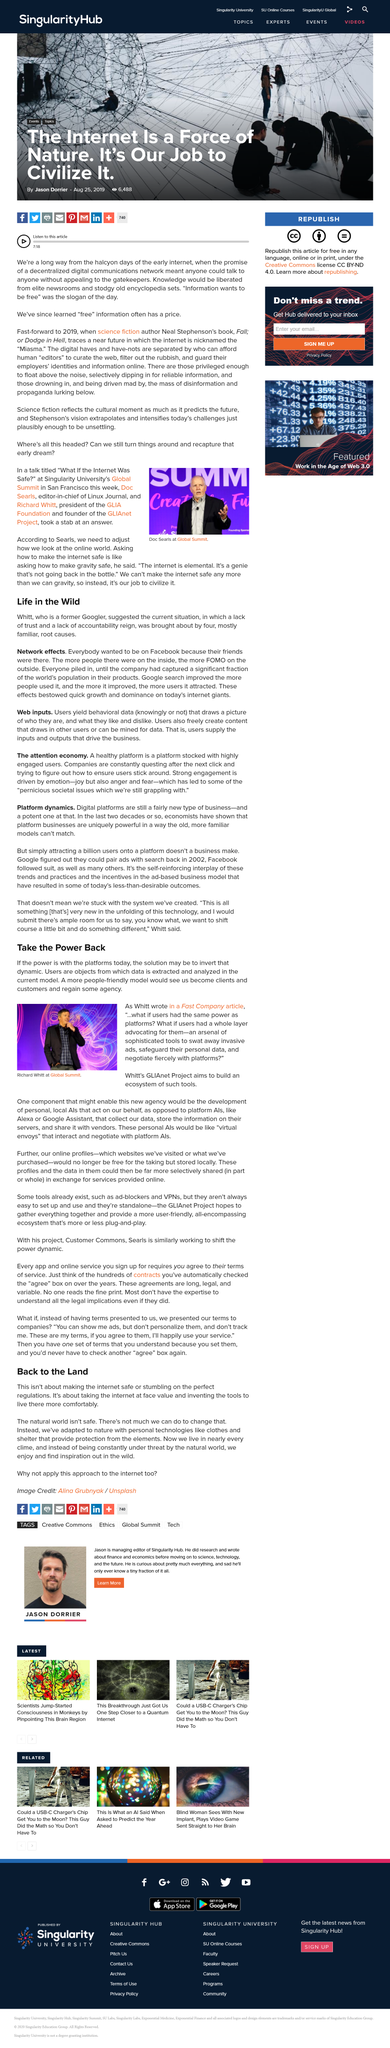List a handful of essential elements in this visual. In the current model, users are considered as objects from which data is extracted and analyzed. As a more people-friendly model, we would transition from being mere clients and customers, to being valued and respected partners in the process. In his article for Fast Company, Whitt posed the question, 'what if users had the same power as platforms?' and aimed to build an ecosystem of tools through the GLIAnet Project to empower users with the power of platforms. The person depicted in the photograph is Doc Searls. The picture is being taken from a location known as "The Global Summit. 